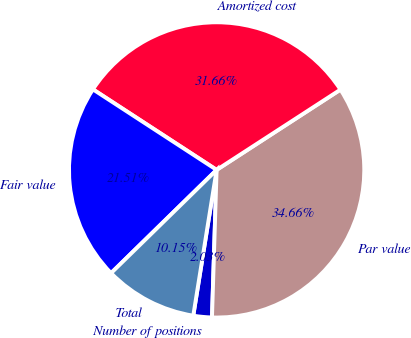Convert chart to OTSL. <chart><loc_0><loc_0><loc_500><loc_500><pie_chart><fcel>Number of positions<fcel>Par value<fcel>Amortized cost<fcel>Fair value<fcel>Total<nl><fcel>2.03%<fcel>34.66%<fcel>31.66%<fcel>21.51%<fcel>10.15%<nl></chart> 